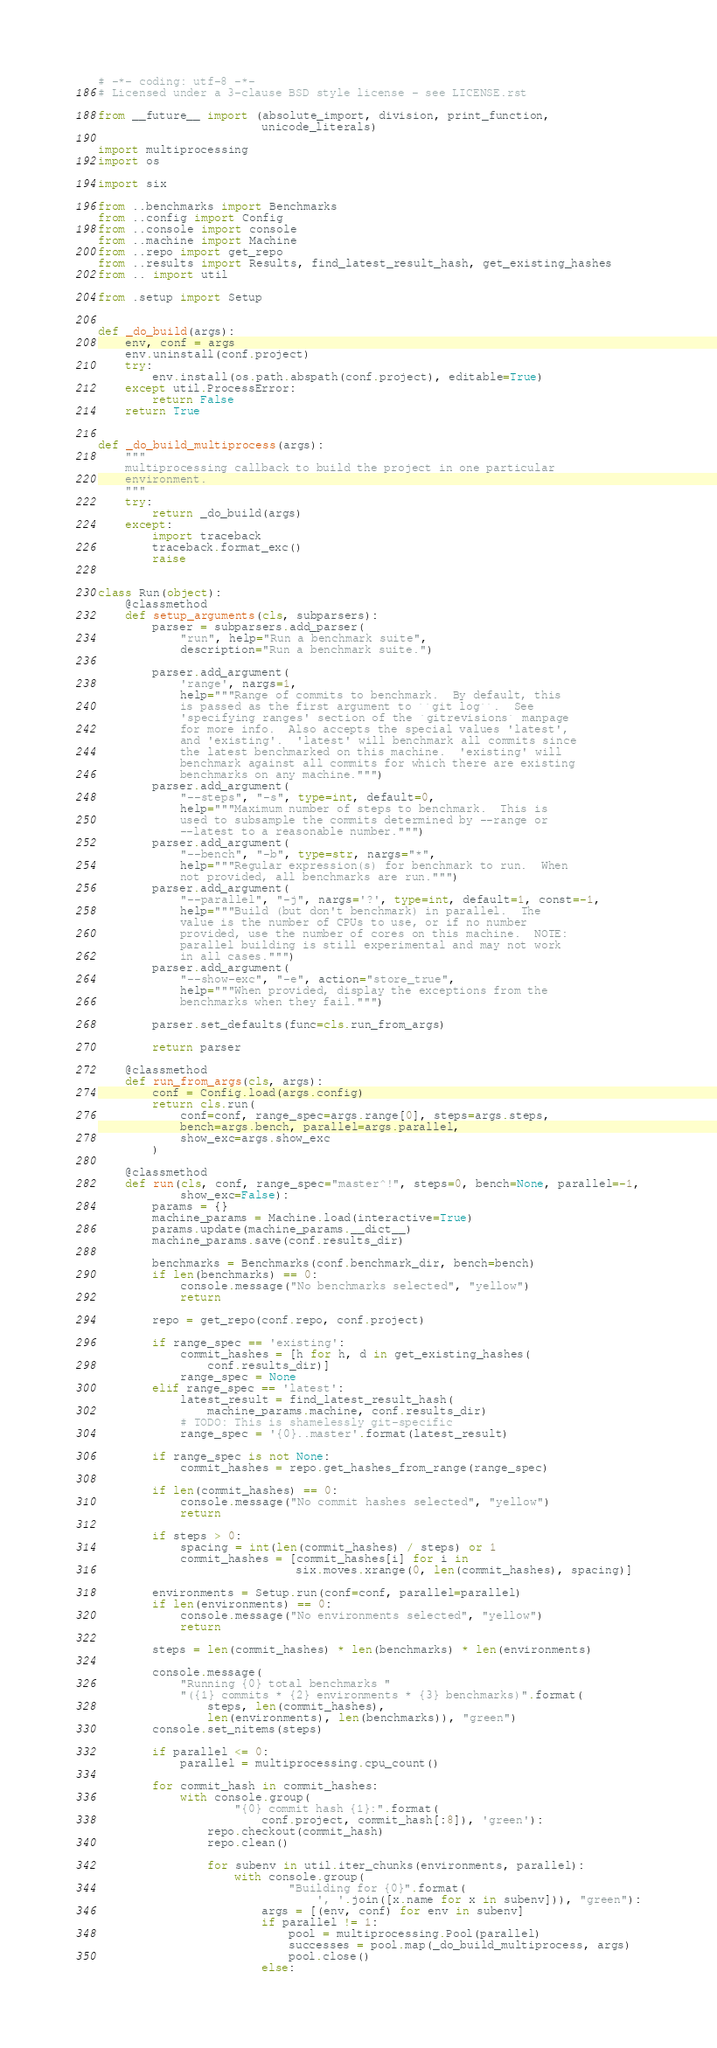<code> <loc_0><loc_0><loc_500><loc_500><_Python_># -*- coding: utf-8 -*-
# Licensed under a 3-clause BSD style license - see LICENSE.rst

from __future__ import (absolute_import, division, print_function,
                        unicode_literals)

import multiprocessing
import os

import six

from ..benchmarks import Benchmarks
from ..config import Config
from ..console import console
from ..machine import Machine
from ..repo import get_repo
from ..results import Results, find_latest_result_hash, get_existing_hashes
from .. import util

from .setup import Setup


def _do_build(args):
    env, conf = args
    env.uninstall(conf.project)
    try:
        env.install(os.path.abspath(conf.project), editable=True)
    except util.ProcessError:
        return False
    return True


def _do_build_multiprocess(args):
    """
    multiprocessing callback to build the project in one particular
    environment.
    """
    try:
        return _do_build(args)
    except:
        import traceback
        traceback.format_exc()
        raise


class Run(object):
    @classmethod
    def setup_arguments(cls, subparsers):
        parser = subparsers.add_parser(
            "run", help="Run a benchmark suite",
            description="Run a benchmark suite.")

        parser.add_argument(
            'range', nargs=1,
            help="""Range of commits to benchmark.  By default, this
            is passed as the first argument to ``git log``.  See
            'specifying ranges' section of the `gitrevisions` manpage
            for more info.  Also accepts the special values 'latest',
            and 'existing'.  'latest' will benchmark all commits since
            the latest benchmarked on this machine.  'existing' will
            benchmark against all commits for which there are existing
            benchmarks on any machine.""")
        parser.add_argument(
            "--steps", "-s", type=int, default=0,
            help="""Maximum number of steps to benchmark.  This is
            used to subsample the commits determined by --range or
            --latest to a reasonable number.""")
        parser.add_argument(
            "--bench", "-b", type=str, nargs="*",
            help="""Regular expression(s) for benchmark to run.  When
            not provided, all benchmarks are run.""")
        parser.add_argument(
            "--parallel", "-j", nargs='?', type=int, default=1, const=-1,
            help="""Build (but don't benchmark) in parallel.  The
            value is the number of CPUs to use, or if no number
            provided, use the number of cores on this machine.  NOTE:
            parallel building is still experimental and may not work
            in all cases.""")
        parser.add_argument(
            "--show-exc", "-e", action="store_true",
            help="""When provided, display the exceptions from the
            benchmarks when they fail.""")

        parser.set_defaults(func=cls.run_from_args)

        return parser

    @classmethod
    def run_from_args(cls, args):
        conf = Config.load(args.config)
        return cls.run(
            conf=conf, range_spec=args.range[0], steps=args.steps,
            bench=args.bench, parallel=args.parallel,
            show_exc=args.show_exc
        )

    @classmethod
    def run(cls, conf, range_spec="master^!", steps=0, bench=None, parallel=-1,
            show_exc=False):
        params = {}
        machine_params = Machine.load(interactive=True)
        params.update(machine_params.__dict__)
        machine_params.save(conf.results_dir)

        benchmarks = Benchmarks(conf.benchmark_dir, bench=bench)
        if len(benchmarks) == 0:
            console.message("No benchmarks selected", "yellow")
            return

        repo = get_repo(conf.repo, conf.project)

        if range_spec == 'existing':
            commit_hashes = [h for h, d in get_existing_hashes(
                conf.results_dir)]
            range_spec = None
        elif range_spec == 'latest':
            latest_result = find_latest_result_hash(
                machine_params.machine, conf.results_dir)
            # TODO: This is shamelessly git-specific
            range_spec = '{0}..master'.format(latest_result)

        if range_spec is not None:
            commit_hashes = repo.get_hashes_from_range(range_spec)

        if len(commit_hashes) == 0:
            console.message("No commit hashes selected", "yellow")
            return

        if steps > 0:
            spacing = int(len(commit_hashes) / steps) or 1
            commit_hashes = [commit_hashes[i] for i in
                             six.moves.xrange(0, len(commit_hashes), spacing)]

        environments = Setup.run(conf=conf, parallel=parallel)
        if len(environments) == 0:
            console.message("No environments selected", "yellow")
            return

        steps = len(commit_hashes) * len(benchmarks) * len(environments)

        console.message(
            "Running {0} total benchmarks "
            "({1} commits * {2} environments * {3} benchmarks)".format(
                steps, len(commit_hashes),
                len(environments), len(benchmarks)), "green")
        console.set_nitems(steps)

        if parallel <= 0:
            parallel = multiprocessing.cpu_count()

        for commit_hash in commit_hashes:
            with console.group(
                    "{0} commit hash {1}:".format(
                        conf.project, commit_hash[:8]), 'green'):
                repo.checkout(commit_hash)
                repo.clean()

                for subenv in util.iter_chunks(environments, parallel):
                    with console.group(
                            "Building for {0}".format(
                                ', '.join([x.name for x in subenv])), "green"):
                        args = [(env, conf) for env in subenv]
                        if parallel != 1:
                            pool = multiprocessing.Pool(parallel)
                            successes = pool.map(_do_build_multiprocess, args)
                            pool.close()
                        else:</code> 